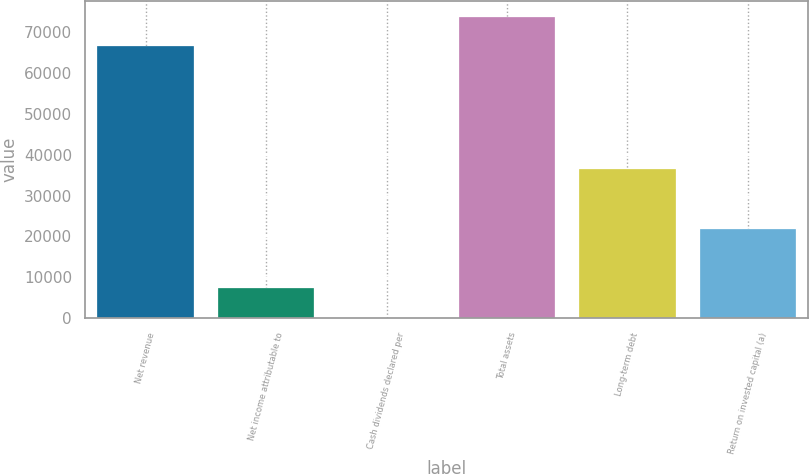<chart> <loc_0><loc_0><loc_500><loc_500><bar_chart><fcel>Net revenue<fcel>Net income attributable to<fcel>Cash dividends declared per<fcel>Total assets<fcel>Long-term debt<fcel>Return on invested capital (a)<nl><fcel>66504<fcel>7290.02<fcel>2.02<fcel>73792<fcel>36442<fcel>21866<nl></chart> 